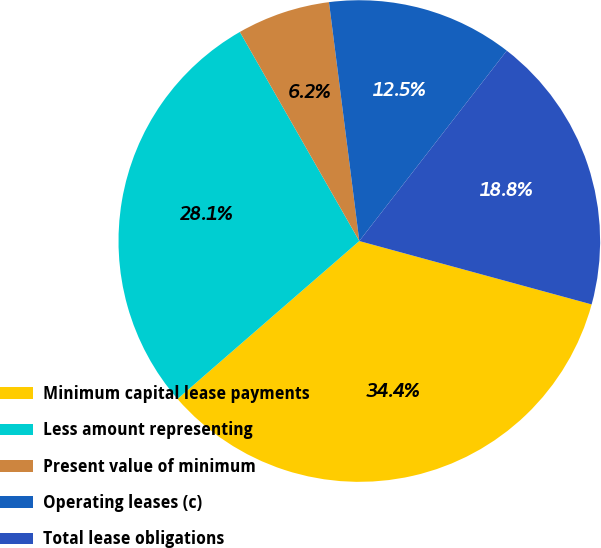Convert chart. <chart><loc_0><loc_0><loc_500><loc_500><pie_chart><fcel>Minimum capital lease payments<fcel>Less amount representing<fcel>Present value of minimum<fcel>Operating leases (c)<fcel>Total lease obligations<nl><fcel>34.38%<fcel>28.12%<fcel>6.25%<fcel>12.5%<fcel>18.75%<nl></chart> 